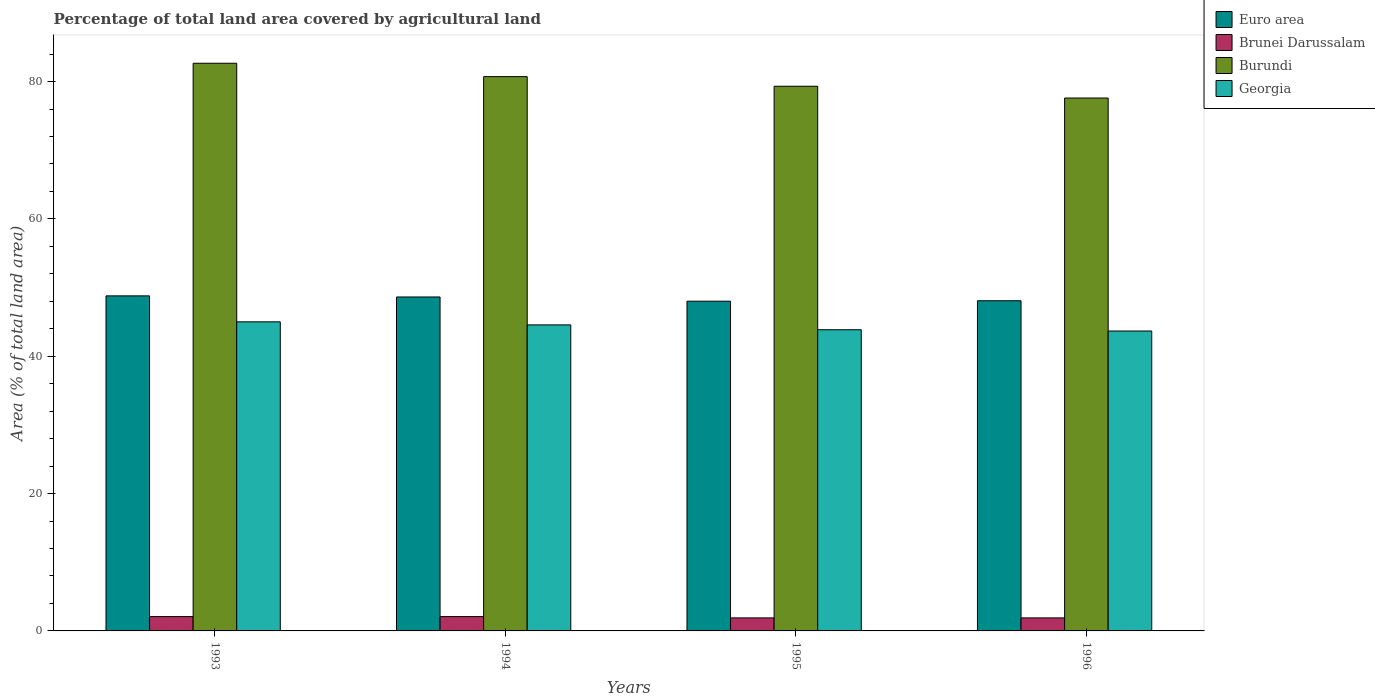How many groups of bars are there?
Give a very brief answer. 4. Are the number of bars per tick equal to the number of legend labels?
Your response must be concise. Yes. Are the number of bars on each tick of the X-axis equal?
Provide a short and direct response. Yes. How many bars are there on the 2nd tick from the right?
Your answer should be very brief. 4. What is the label of the 2nd group of bars from the left?
Keep it short and to the point. 1994. In how many cases, is the number of bars for a given year not equal to the number of legend labels?
Offer a terse response. 0. What is the percentage of agricultural land in Brunei Darussalam in 1996?
Your response must be concise. 1.9. Across all years, what is the maximum percentage of agricultural land in Burundi?
Keep it short and to the point. 82.67. Across all years, what is the minimum percentage of agricultural land in Euro area?
Give a very brief answer. 48.02. In which year was the percentage of agricultural land in Burundi maximum?
Provide a succinct answer. 1993. What is the total percentage of agricultural land in Brunei Darussalam in the graph?
Offer a very short reply. 7.97. What is the difference between the percentage of agricultural land in Burundi in 1995 and that in 1996?
Make the answer very short. 1.71. What is the difference between the percentage of agricultural land in Brunei Darussalam in 1996 and the percentage of agricultural land in Burundi in 1994?
Your answer should be compact. -78.83. What is the average percentage of agricultural land in Euro area per year?
Offer a terse response. 48.38. In the year 1995, what is the difference between the percentage of agricultural land in Brunei Darussalam and percentage of agricultural land in Georgia?
Make the answer very short. -41.96. In how many years, is the percentage of agricultural land in Burundi greater than 44 %?
Keep it short and to the point. 4. What is the ratio of the percentage of agricultural land in Georgia in 1993 to that in 1994?
Keep it short and to the point. 1.01. What is the difference between the highest and the second highest percentage of agricultural land in Burundi?
Offer a terse response. 1.95. What is the difference between the highest and the lowest percentage of agricultural land in Georgia?
Ensure brevity in your answer.  1.34. In how many years, is the percentage of agricultural land in Georgia greater than the average percentage of agricultural land in Georgia taken over all years?
Provide a succinct answer. 2. Is the sum of the percentage of agricultural land in Euro area in 1993 and 1994 greater than the maximum percentage of agricultural land in Georgia across all years?
Make the answer very short. Yes. Is it the case that in every year, the sum of the percentage of agricultural land in Georgia and percentage of agricultural land in Burundi is greater than the sum of percentage of agricultural land in Euro area and percentage of agricultural land in Brunei Darussalam?
Make the answer very short. Yes. What does the 4th bar from the left in 1993 represents?
Your answer should be compact. Georgia. What does the 3rd bar from the right in 1996 represents?
Keep it short and to the point. Brunei Darussalam. How many bars are there?
Give a very brief answer. 16. How many years are there in the graph?
Offer a very short reply. 4. What is the difference between two consecutive major ticks on the Y-axis?
Your answer should be compact. 20. Are the values on the major ticks of Y-axis written in scientific E-notation?
Make the answer very short. No. Does the graph contain any zero values?
Ensure brevity in your answer.  No. Does the graph contain grids?
Your answer should be very brief. No. Where does the legend appear in the graph?
Offer a very short reply. Top right. How are the legend labels stacked?
Keep it short and to the point. Vertical. What is the title of the graph?
Give a very brief answer. Percentage of total land area covered by agricultural land. Does "Saudi Arabia" appear as one of the legend labels in the graph?
Offer a terse response. No. What is the label or title of the X-axis?
Your answer should be very brief. Years. What is the label or title of the Y-axis?
Provide a succinct answer. Area (% of total land area). What is the Area (% of total land area) in Euro area in 1993?
Your response must be concise. 48.79. What is the Area (% of total land area) in Brunei Darussalam in 1993?
Keep it short and to the point. 2.09. What is the Area (% of total land area) in Burundi in 1993?
Ensure brevity in your answer.  82.67. What is the Area (% of total land area) of Georgia in 1993?
Make the answer very short. 45.01. What is the Area (% of total land area) in Euro area in 1994?
Give a very brief answer. 48.63. What is the Area (% of total land area) of Brunei Darussalam in 1994?
Offer a very short reply. 2.09. What is the Area (% of total land area) of Burundi in 1994?
Give a very brief answer. 80.72. What is the Area (% of total land area) of Georgia in 1994?
Offer a very short reply. 44.57. What is the Area (% of total land area) of Euro area in 1995?
Offer a terse response. 48.02. What is the Area (% of total land area) of Brunei Darussalam in 1995?
Provide a succinct answer. 1.9. What is the Area (% of total land area) in Burundi in 1995?
Provide a succinct answer. 79.32. What is the Area (% of total land area) of Georgia in 1995?
Your answer should be very brief. 43.86. What is the Area (% of total land area) in Euro area in 1996?
Make the answer very short. 48.08. What is the Area (% of total land area) in Brunei Darussalam in 1996?
Your answer should be very brief. 1.9. What is the Area (% of total land area) in Burundi in 1996?
Offer a terse response. 77.61. What is the Area (% of total land area) of Georgia in 1996?
Make the answer very short. 43.68. Across all years, what is the maximum Area (% of total land area) of Euro area?
Your answer should be very brief. 48.79. Across all years, what is the maximum Area (% of total land area) of Brunei Darussalam?
Keep it short and to the point. 2.09. Across all years, what is the maximum Area (% of total land area) of Burundi?
Provide a short and direct response. 82.67. Across all years, what is the maximum Area (% of total land area) in Georgia?
Your answer should be compact. 45.01. Across all years, what is the minimum Area (% of total land area) in Euro area?
Ensure brevity in your answer.  48.02. Across all years, what is the minimum Area (% of total land area) of Brunei Darussalam?
Your answer should be compact. 1.9. Across all years, what is the minimum Area (% of total land area) in Burundi?
Ensure brevity in your answer.  77.61. Across all years, what is the minimum Area (% of total land area) of Georgia?
Ensure brevity in your answer.  43.68. What is the total Area (% of total land area) in Euro area in the graph?
Make the answer very short. 193.53. What is the total Area (% of total land area) of Brunei Darussalam in the graph?
Your answer should be very brief. 7.97. What is the total Area (% of total land area) in Burundi in the graph?
Offer a very short reply. 320.33. What is the total Area (% of total land area) of Georgia in the graph?
Your answer should be very brief. 177.12. What is the difference between the Area (% of total land area) of Euro area in 1993 and that in 1994?
Provide a short and direct response. 0.16. What is the difference between the Area (% of total land area) in Brunei Darussalam in 1993 and that in 1994?
Your answer should be compact. 0. What is the difference between the Area (% of total land area) in Burundi in 1993 and that in 1994?
Make the answer very short. 1.95. What is the difference between the Area (% of total land area) in Georgia in 1993 and that in 1994?
Provide a succinct answer. 0.45. What is the difference between the Area (% of total land area) in Euro area in 1993 and that in 1995?
Provide a short and direct response. 0.78. What is the difference between the Area (% of total land area) in Brunei Darussalam in 1993 and that in 1995?
Ensure brevity in your answer.  0.19. What is the difference between the Area (% of total land area) in Burundi in 1993 and that in 1995?
Offer a terse response. 3.35. What is the difference between the Area (% of total land area) in Georgia in 1993 and that in 1995?
Offer a terse response. 1.15. What is the difference between the Area (% of total land area) of Euro area in 1993 and that in 1996?
Your answer should be compact. 0.71. What is the difference between the Area (% of total land area) of Brunei Darussalam in 1993 and that in 1996?
Your answer should be compact. 0.19. What is the difference between the Area (% of total land area) of Burundi in 1993 and that in 1996?
Keep it short and to the point. 5.06. What is the difference between the Area (% of total land area) in Georgia in 1993 and that in 1996?
Provide a short and direct response. 1.34. What is the difference between the Area (% of total land area) of Euro area in 1994 and that in 1995?
Ensure brevity in your answer.  0.62. What is the difference between the Area (% of total land area) in Brunei Darussalam in 1994 and that in 1995?
Ensure brevity in your answer.  0.19. What is the difference between the Area (% of total land area) in Burundi in 1994 and that in 1995?
Keep it short and to the point. 1.4. What is the difference between the Area (% of total land area) in Georgia in 1994 and that in 1995?
Offer a very short reply. 0.71. What is the difference between the Area (% of total land area) in Euro area in 1994 and that in 1996?
Give a very brief answer. 0.55. What is the difference between the Area (% of total land area) in Brunei Darussalam in 1994 and that in 1996?
Your response must be concise. 0.19. What is the difference between the Area (% of total land area) in Burundi in 1994 and that in 1996?
Offer a terse response. 3.12. What is the difference between the Area (% of total land area) of Georgia in 1994 and that in 1996?
Keep it short and to the point. 0.89. What is the difference between the Area (% of total land area) in Euro area in 1995 and that in 1996?
Ensure brevity in your answer.  -0.06. What is the difference between the Area (% of total land area) of Brunei Darussalam in 1995 and that in 1996?
Your response must be concise. 0. What is the difference between the Area (% of total land area) in Burundi in 1995 and that in 1996?
Make the answer very short. 1.71. What is the difference between the Area (% of total land area) of Georgia in 1995 and that in 1996?
Keep it short and to the point. 0.19. What is the difference between the Area (% of total land area) in Euro area in 1993 and the Area (% of total land area) in Brunei Darussalam in 1994?
Provide a short and direct response. 46.71. What is the difference between the Area (% of total land area) of Euro area in 1993 and the Area (% of total land area) of Burundi in 1994?
Keep it short and to the point. -31.93. What is the difference between the Area (% of total land area) in Euro area in 1993 and the Area (% of total land area) in Georgia in 1994?
Your answer should be compact. 4.23. What is the difference between the Area (% of total land area) in Brunei Darussalam in 1993 and the Area (% of total land area) in Burundi in 1994?
Your answer should be very brief. -78.64. What is the difference between the Area (% of total land area) of Brunei Darussalam in 1993 and the Area (% of total land area) of Georgia in 1994?
Make the answer very short. -42.48. What is the difference between the Area (% of total land area) in Burundi in 1993 and the Area (% of total land area) in Georgia in 1994?
Your answer should be compact. 38.1. What is the difference between the Area (% of total land area) in Euro area in 1993 and the Area (% of total land area) in Brunei Darussalam in 1995?
Offer a terse response. 46.9. What is the difference between the Area (% of total land area) of Euro area in 1993 and the Area (% of total land area) of Burundi in 1995?
Provide a short and direct response. -30.53. What is the difference between the Area (% of total land area) of Euro area in 1993 and the Area (% of total land area) of Georgia in 1995?
Provide a short and direct response. 4.93. What is the difference between the Area (% of total land area) of Brunei Darussalam in 1993 and the Area (% of total land area) of Burundi in 1995?
Your response must be concise. -77.24. What is the difference between the Area (% of total land area) in Brunei Darussalam in 1993 and the Area (% of total land area) in Georgia in 1995?
Give a very brief answer. -41.78. What is the difference between the Area (% of total land area) in Burundi in 1993 and the Area (% of total land area) in Georgia in 1995?
Your answer should be very brief. 38.81. What is the difference between the Area (% of total land area) in Euro area in 1993 and the Area (% of total land area) in Brunei Darussalam in 1996?
Provide a succinct answer. 46.9. What is the difference between the Area (% of total land area) in Euro area in 1993 and the Area (% of total land area) in Burundi in 1996?
Your response must be concise. -28.81. What is the difference between the Area (% of total land area) of Euro area in 1993 and the Area (% of total land area) of Georgia in 1996?
Offer a terse response. 5.12. What is the difference between the Area (% of total land area) in Brunei Darussalam in 1993 and the Area (% of total land area) in Burundi in 1996?
Keep it short and to the point. -75.52. What is the difference between the Area (% of total land area) of Brunei Darussalam in 1993 and the Area (% of total land area) of Georgia in 1996?
Offer a very short reply. -41.59. What is the difference between the Area (% of total land area) of Burundi in 1993 and the Area (% of total land area) of Georgia in 1996?
Make the answer very short. 39. What is the difference between the Area (% of total land area) of Euro area in 1994 and the Area (% of total land area) of Brunei Darussalam in 1995?
Keep it short and to the point. 46.74. What is the difference between the Area (% of total land area) in Euro area in 1994 and the Area (% of total land area) in Burundi in 1995?
Make the answer very short. -30.69. What is the difference between the Area (% of total land area) in Euro area in 1994 and the Area (% of total land area) in Georgia in 1995?
Give a very brief answer. 4.77. What is the difference between the Area (% of total land area) in Brunei Darussalam in 1994 and the Area (% of total land area) in Burundi in 1995?
Ensure brevity in your answer.  -77.24. What is the difference between the Area (% of total land area) in Brunei Darussalam in 1994 and the Area (% of total land area) in Georgia in 1995?
Ensure brevity in your answer.  -41.78. What is the difference between the Area (% of total land area) in Burundi in 1994 and the Area (% of total land area) in Georgia in 1995?
Ensure brevity in your answer.  36.86. What is the difference between the Area (% of total land area) in Euro area in 1994 and the Area (% of total land area) in Brunei Darussalam in 1996?
Provide a succinct answer. 46.74. What is the difference between the Area (% of total land area) in Euro area in 1994 and the Area (% of total land area) in Burundi in 1996?
Provide a succinct answer. -28.98. What is the difference between the Area (% of total land area) of Euro area in 1994 and the Area (% of total land area) of Georgia in 1996?
Give a very brief answer. 4.96. What is the difference between the Area (% of total land area) in Brunei Darussalam in 1994 and the Area (% of total land area) in Burundi in 1996?
Your answer should be compact. -75.52. What is the difference between the Area (% of total land area) in Brunei Darussalam in 1994 and the Area (% of total land area) in Georgia in 1996?
Ensure brevity in your answer.  -41.59. What is the difference between the Area (% of total land area) of Burundi in 1994 and the Area (% of total land area) of Georgia in 1996?
Ensure brevity in your answer.  37.05. What is the difference between the Area (% of total land area) of Euro area in 1995 and the Area (% of total land area) of Brunei Darussalam in 1996?
Make the answer very short. 46.12. What is the difference between the Area (% of total land area) of Euro area in 1995 and the Area (% of total land area) of Burundi in 1996?
Keep it short and to the point. -29.59. What is the difference between the Area (% of total land area) of Euro area in 1995 and the Area (% of total land area) of Georgia in 1996?
Your answer should be compact. 4.34. What is the difference between the Area (% of total land area) in Brunei Darussalam in 1995 and the Area (% of total land area) in Burundi in 1996?
Make the answer very short. -75.71. What is the difference between the Area (% of total land area) of Brunei Darussalam in 1995 and the Area (% of total land area) of Georgia in 1996?
Your answer should be compact. -41.78. What is the difference between the Area (% of total land area) of Burundi in 1995 and the Area (% of total land area) of Georgia in 1996?
Keep it short and to the point. 35.65. What is the average Area (% of total land area) in Euro area per year?
Offer a terse response. 48.38. What is the average Area (% of total land area) of Brunei Darussalam per year?
Your answer should be very brief. 1.99. What is the average Area (% of total land area) in Burundi per year?
Give a very brief answer. 80.08. What is the average Area (% of total land area) in Georgia per year?
Your answer should be compact. 44.28. In the year 1993, what is the difference between the Area (% of total land area) of Euro area and Area (% of total land area) of Brunei Darussalam?
Offer a terse response. 46.71. In the year 1993, what is the difference between the Area (% of total land area) of Euro area and Area (% of total land area) of Burundi?
Keep it short and to the point. -33.88. In the year 1993, what is the difference between the Area (% of total land area) of Euro area and Area (% of total land area) of Georgia?
Offer a very short reply. 3.78. In the year 1993, what is the difference between the Area (% of total land area) of Brunei Darussalam and Area (% of total land area) of Burundi?
Your response must be concise. -80.58. In the year 1993, what is the difference between the Area (% of total land area) of Brunei Darussalam and Area (% of total land area) of Georgia?
Your response must be concise. -42.93. In the year 1993, what is the difference between the Area (% of total land area) of Burundi and Area (% of total land area) of Georgia?
Offer a terse response. 37.66. In the year 1994, what is the difference between the Area (% of total land area) of Euro area and Area (% of total land area) of Brunei Darussalam?
Your response must be concise. 46.55. In the year 1994, what is the difference between the Area (% of total land area) of Euro area and Area (% of total land area) of Burundi?
Your answer should be compact. -32.09. In the year 1994, what is the difference between the Area (% of total land area) of Euro area and Area (% of total land area) of Georgia?
Your answer should be compact. 4.07. In the year 1994, what is the difference between the Area (% of total land area) in Brunei Darussalam and Area (% of total land area) in Burundi?
Your answer should be very brief. -78.64. In the year 1994, what is the difference between the Area (% of total land area) of Brunei Darussalam and Area (% of total land area) of Georgia?
Keep it short and to the point. -42.48. In the year 1994, what is the difference between the Area (% of total land area) in Burundi and Area (% of total land area) in Georgia?
Offer a terse response. 36.16. In the year 1995, what is the difference between the Area (% of total land area) of Euro area and Area (% of total land area) of Brunei Darussalam?
Ensure brevity in your answer.  46.12. In the year 1995, what is the difference between the Area (% of total land area) in Euro area and Area (% of total land area) in Burundi?
Provide a short and direct response. -31.3. In the year 1995, what is the difference between the Area (% of total land area) of Euro area and Area (% of total land area) of Georgia?
Provide a short and direct response. 4.16. In the year 1995, what is the difference between the Area (% of total land area) of Brunei Darussalam and Area (% of total land area) of Burundi?
Provide a short and direct response. -77.42. In the year 1995, what is the difference between the Area (% of total land area) in Brunei Darussalam and Area (% of total land area) in Georgia?
Offer a terse response. -41.96. In the year 1995, what is the difference between the Area (% of total land area) of Burundi and Area (% of total land area) of Georgia?
Your answer should be very brief. 35.46. In the year 1996, what is the difference between the Area (% of total land area) of Euro area and Area (% of total land area) of Brunei Darussalam?
Your answer should be very brief. 46.19. In the year 1996, what is the difference between the Area (% of total land area) in Euro area and Area (% of total land area) in Burundi?
Your answer should be very brief. -29.53. In the year 1996, what is the difference between the Area (% of total land area) of Euro area and Area (% of total land area) of Georgia?
Offer a terse response. 4.41. In the year 1996, what is the difference between the Area (% of total land area) in Brunei Darussalam and Area (% of total land area) in Burundi?
Make the answer very short. -75.71. In the year 1996, what is the difference between the Area (% of total land area) of Brunei Darussalam and Area (% of total land area) of Georgia?
Provide a short and direct response. -41.78. In the year 1996, what is the difference between the Area (% of total land area) in Burundi and Area (% of total land area) in Georgia?
Offer a very short reply. 33.93. What is the ratio of the Area (% of total land area) of Euro area in 1993 to that in 1994?
Provide a succinct answer. 1. What is the ratio of the Area (% of total land area) of Burundi in 1993 to that in 1994?
Your answer should be compact. 1.02. What is the ratio of the Area (% of total land area) of Georgia in 1993 to that in 1994?
Offer a very short reply. 1.01. What is the ratio of the Area (% of total land area) in Euro area in 1993 to that in 1995?
Ensure brevity in your answer.  1.02. What is the ratio of the Area (% of total land area) in Burundi in 1993 to that in 1995?
Ensure brevity in your answer.  1.04. What is the ratio of the Area (% of total land area) of Georgia in 1993 to that in 1995?
Your answer should be compact. 1.03. What is the ratio of the Area (% of total land area) in Euro area in 1993 to that in 1996?
Ensure brevity in your answer.  1.01. What is the ratio of the Area (% of total land area) in Burundi in 1993 to that in 1996?
Ensure brevity in your answer.  1.07. What is the ratio of the Area (% of total land area) in Georgia in 1993 to that in 1996?
Offer a very short reply. 1.03. What is the ratio of the Area (% of total land area) in Euro area in 1994 to that in 1995?
Offer a terse response. 1.01. What is the ratio of the Area (% of total land area) in Burundi in 1994 to that in 1995?
Offer a very short reply. 1.02. What is the ratio of the Area (% of total land area) in Georgia in 1994 to that in 1995?
Your answer should be compact. 1.02. What is the ratio of the Area (% of total land area) of Euro area in 1994 to that in 1996?
Your answer should be very brief. 1.01. What is the ratio of the Area (% of total land area) in Burundi in 1994 to that in 1996?
Offer a very short reply. 1.04. What is the ratio of the Area (% of total land area) of Georgia in 1994 to that in 1996?
Give a very brief answer. 1.02. What is the ratio of the Area (% of total land area) in Brunei Darussalam in 1995 to that in 1996?
Keep it short and to the point. 1. What is the ratio of the Area (% of total land area) of Burundi in 1995 to that in 1996?
Your answer should be compact. 1.02. What is the difference between the highest and the second highest Area (% of total land area) of Euro area?
Make the answer very short. 0.16. What is the difference between the highest and the second highest Area (% of total land area) in Burundi?
Keep it short and to the point. 1.95. What is the difference between the highest and the second highest Area (% of total land area) in Georgia?
Give a very brief answer. 0.45. What is the difference between the highest and the lowest Area (% of total land area) in Euro area?
Make the answer very short. 0.78. What is the difference between the highest and the lowest Area (% of total land area) in Brunei Darussalam?
Provide a succinct answer. 0.19. What is the difference between the highest and the lowest Area (% of total land area) of Burundi?
Make the answer very short. 5.06. What is the difference between the highest and the lowest Area (% of total land area) of Georgia?
Provide a short and direct response. 1.34. 